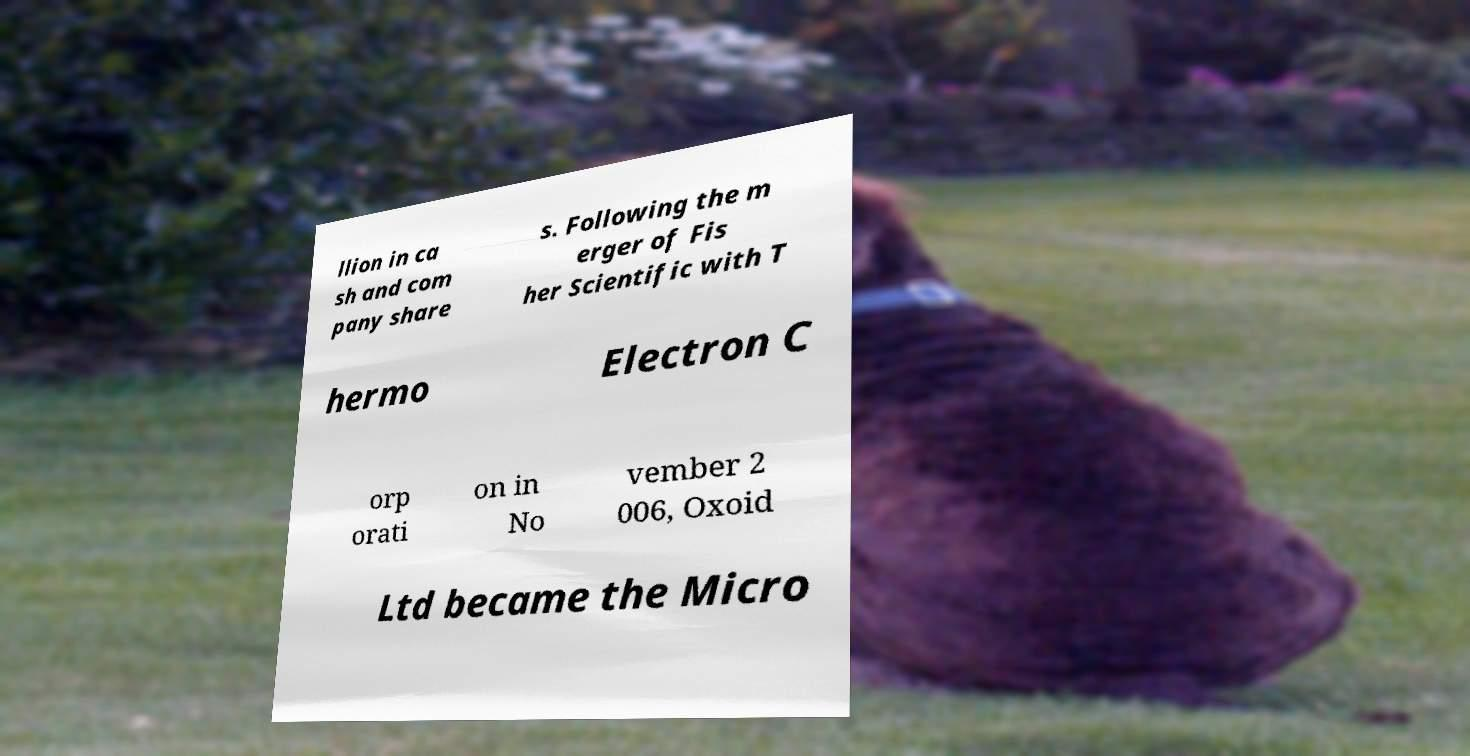There's text embedded in this image that I need extracted. Can you transcribe it verbatim? llion in ca sh and com pany share s. Following the m erger of Fis her Scientific with T hermo Electron C orp orati on in No vember 2 006, Oxoid Ltd became the Micro 